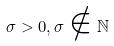Convert formula to latex. <formula><loc_0><loc_0><loc_500><loc_500>\sigma > 0 , \sigma \notin \mathbb { N }</formula> 